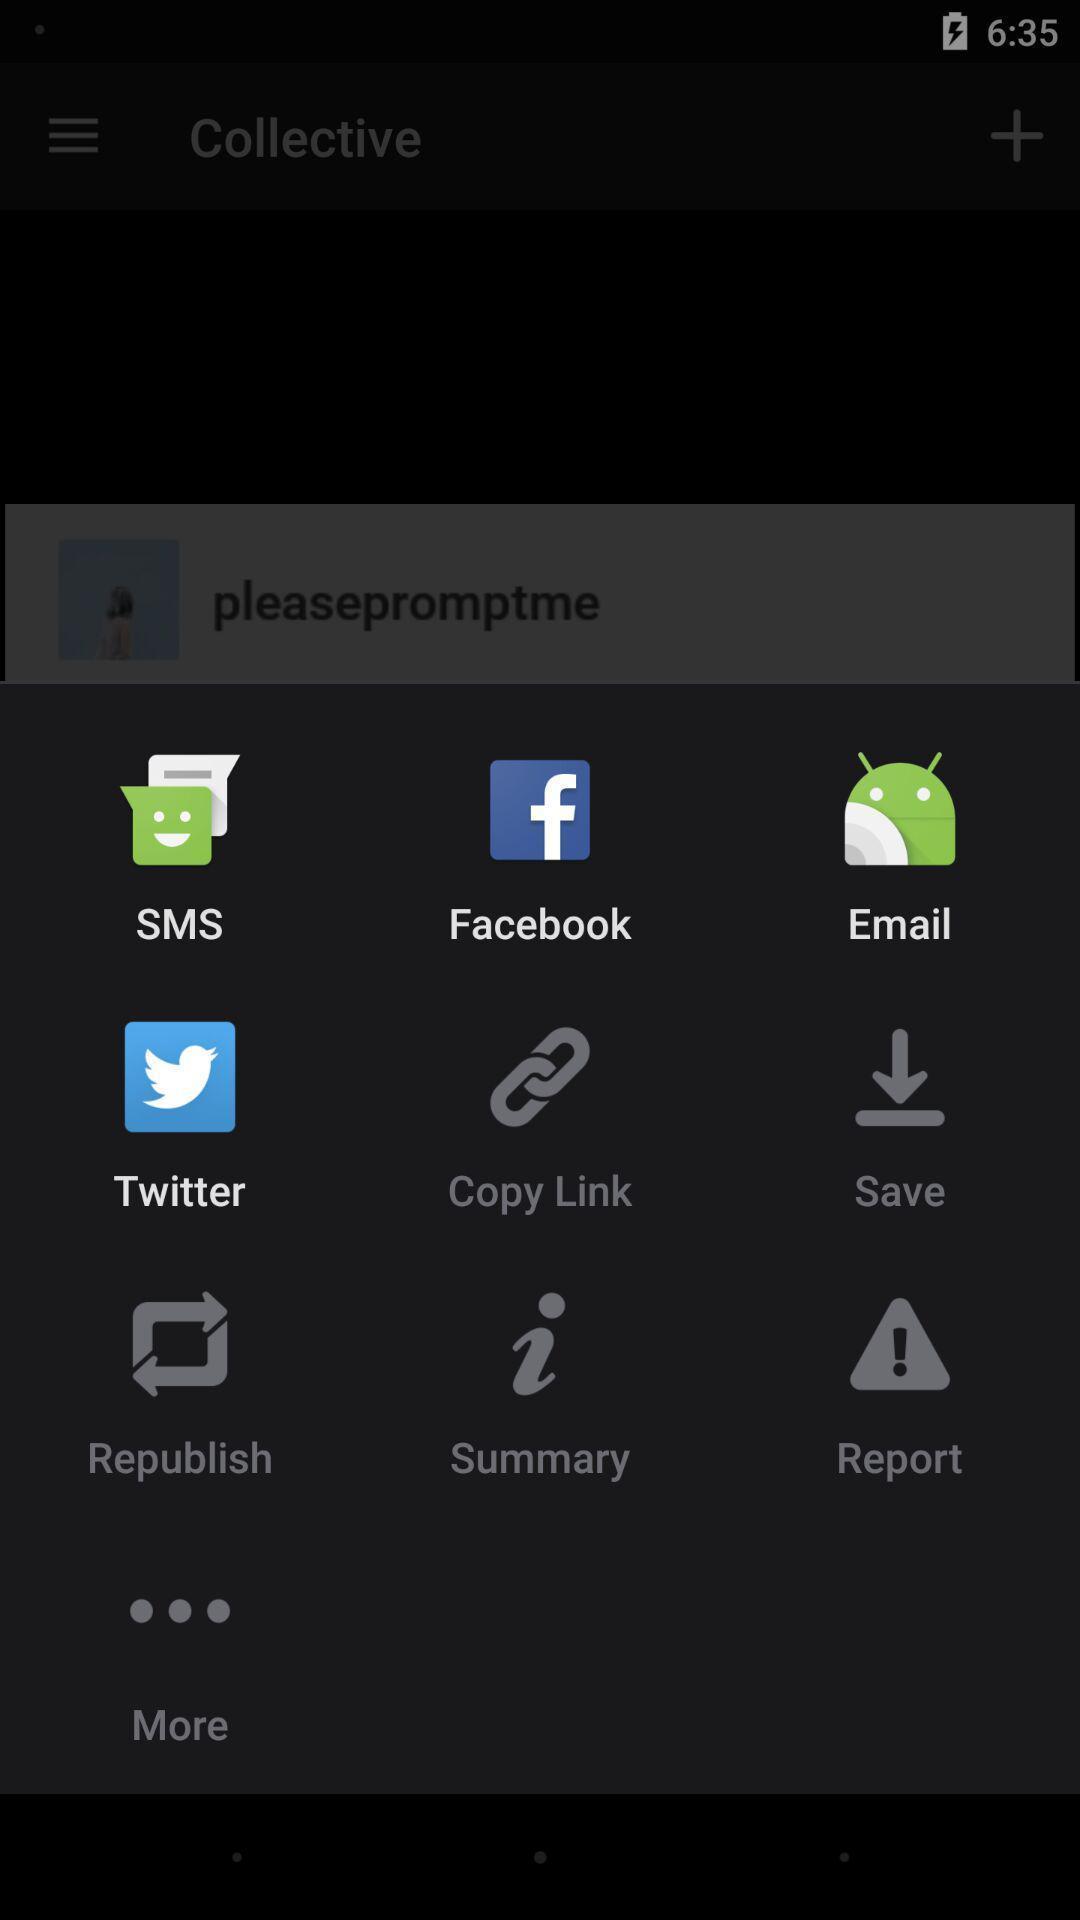Provide a detailed account of this screenshot. Pop up showing different messaging options. 